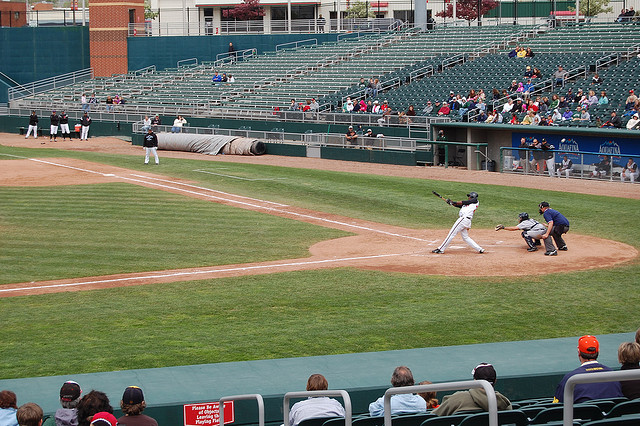Describe a scenario where this game goes into extra innings. In a scenario where this game goes into extra innings, it means that both teams have the sharegpt4v/same score at the end of the regular nine innings. The tension would rise as each team tries to outscore the other in the additional innings. Coaches might make strategic changes, such as substituting pitchers to ensure fresh arms on the mound or bringing in pinch hitters to increase chances of scoring. The crowd would be on the edge of their seats, cheering for every play as the excitement builds with each inning. Possible plays that could determine the game include clutch hits, defensive gems, or even a walk-off home run that sends the home crowd into a frenzy. Extra innings often bring out extraordinary efforts from players, making for a thrilling and memorable finish. 